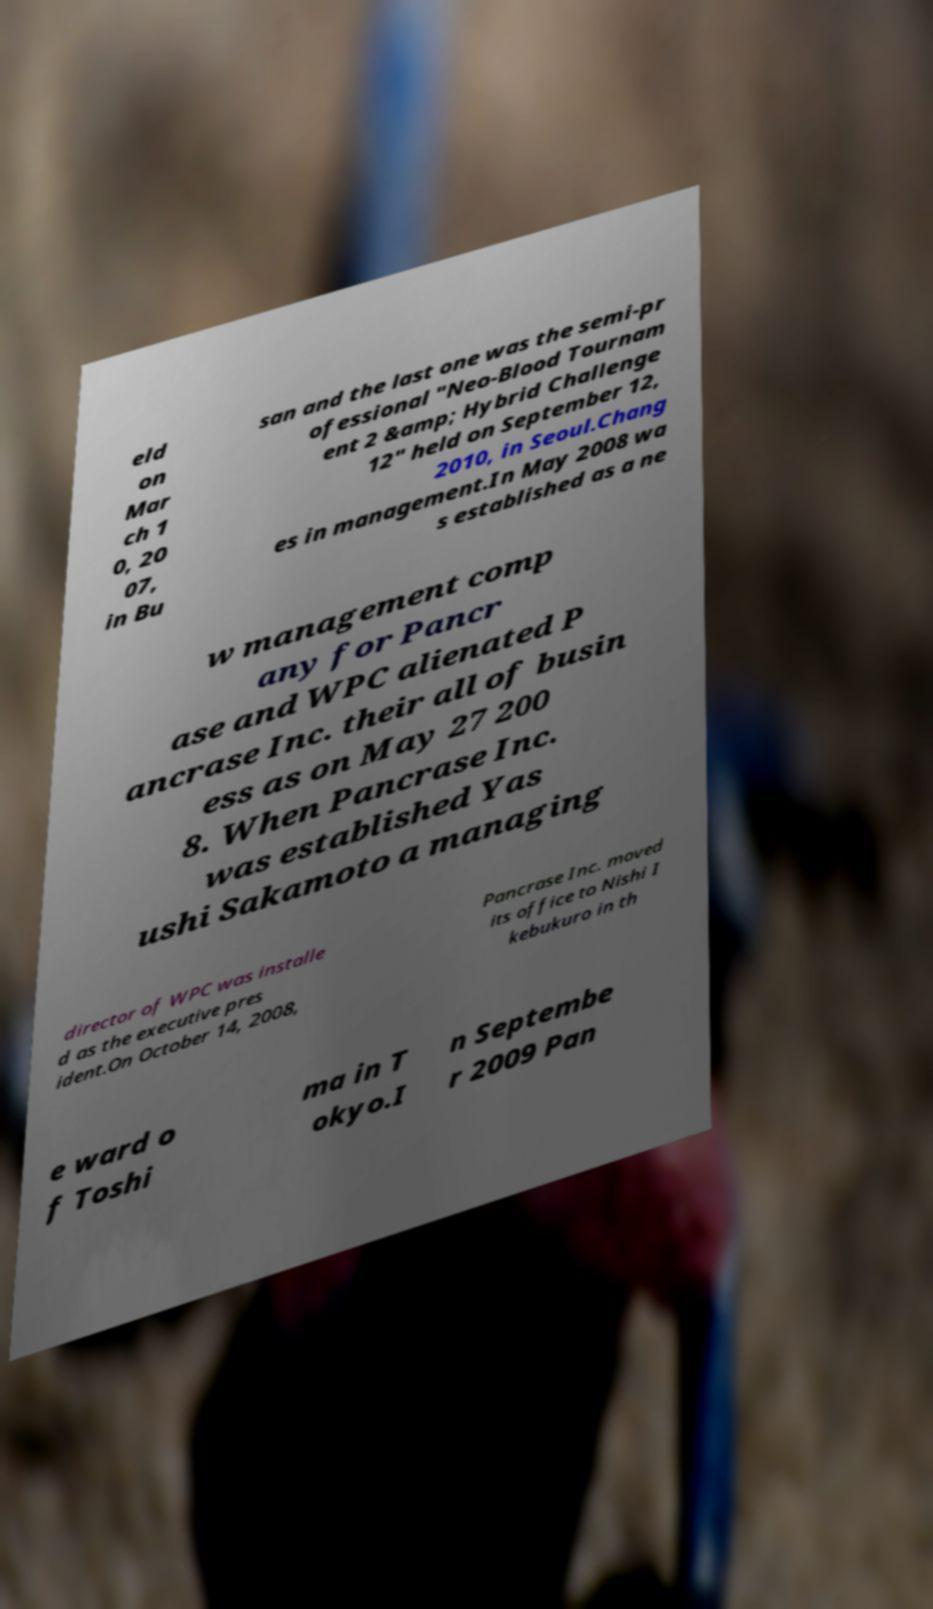What messages or text are displayed in this image? I need them in a readable, typed format. eld on Mar ch 1 0, 20 07, in Bu san and the last one was the semi-pr ofessional "Neo-Blood Tournam ent 2 &amp; Hybrid Challenge 12" held on September 12, 2010, in Seoul.Chang es in management.In May 2008 wa s established as a ne w management comp any for Pancr ase and WPC alienated P ancrase Inc. their all of busin ess as on May 27 200 8. When Pancrase Inc. was established Yas ushi Sakamoto a managing director of WPC was installe d as the executive pres ident.On October 14, 2008, Pancrase Inc. moved its office to Nishi I kebukuro in th e ward o f Toshi ma in T okyo.I n Septembe r 2009 Pan 